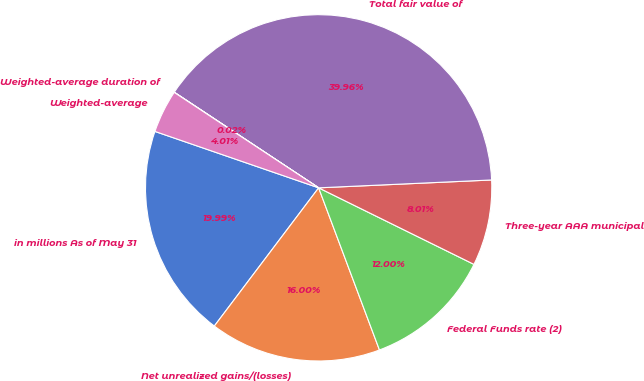Convert chart. <chart><loc_0><loc_0><loc_500><loc_500><pie_chart><fcel>in millions As of May 31<fcel>Net unrealized gains/(losses)<fcel>Federal Funds rate (2)<fcel>Three-year AAA municipal<fcel>Total fair value of<fcel>Weighted-average duration of<fcel>Weighted-average<nl><fcel>19.99%<fcel>16.0%<fcel>12.0%<fcel>8.01%<fcel>39.96%<fcel>0.02%<fcel>4.01%<nl></chart> 